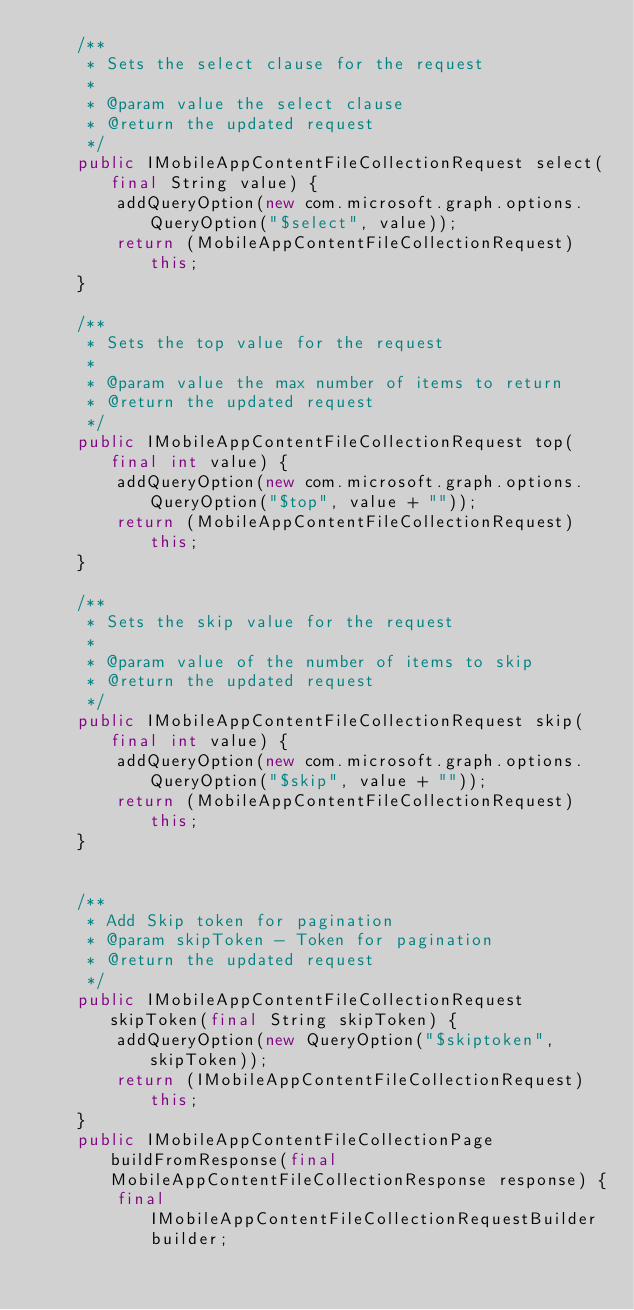Convert code to text. <code><loc_0><loc_0><loc_500><loc_500><_Java_>    /**
     * Sets the select clause for the request
     *
     * @param value the select clause
     * @return the updated request
     */
    public IMobileAppContentFileCollectionRequest select(final String value) {
        addQueryOption(new com.microsoft.graph.options.QueryOption("$select", value));
        return (MobileAppContentFileCollectionRequest)this;
    }

    /**
     * Sets the top value for the request
     *
     * @param value the max number of items to return
     * @return the updated request
     */
    public IMobileAppContentFileCollectionRequest top(final int value) {
        addQueryOption(new com.microsoft.graph.options.QueryOption("$top", value + ""));
        return (MobileAppContentFileCollectionRequest)this;
    }

    /**
     * Sets the skip value for the request
     *
     * @param value of the number of items to skip
     * @return the updated request
     */
    public IMobileAppContentFileCollectionRequest skip(final int value) {
        addQueryOption(new com.microsoft.graph.options.QueryOption("$skip", value + ""));
        return (MobileAppContentFileCollectionRequest)this;
    }


    /**
     * Add Skip token for pagination
     * @param skipToken - Token for pagination
     * @return the updated request
     */
    public IMobileAppContentFileCollectionRequest skipToken(final String skipToken) {
    	addQueryOption(new QueryOption("$skiptoken", skipToken));
        return (IMobileAppContentFileCollectionRequest)this;
    }
    public IMobileAppContentFileCollectionPage buildFromResponse(final MobileAppContentFileCollectionResponse response) {
        final IMobileAppContentFileCollectionRequestBuilder builder;</code> 